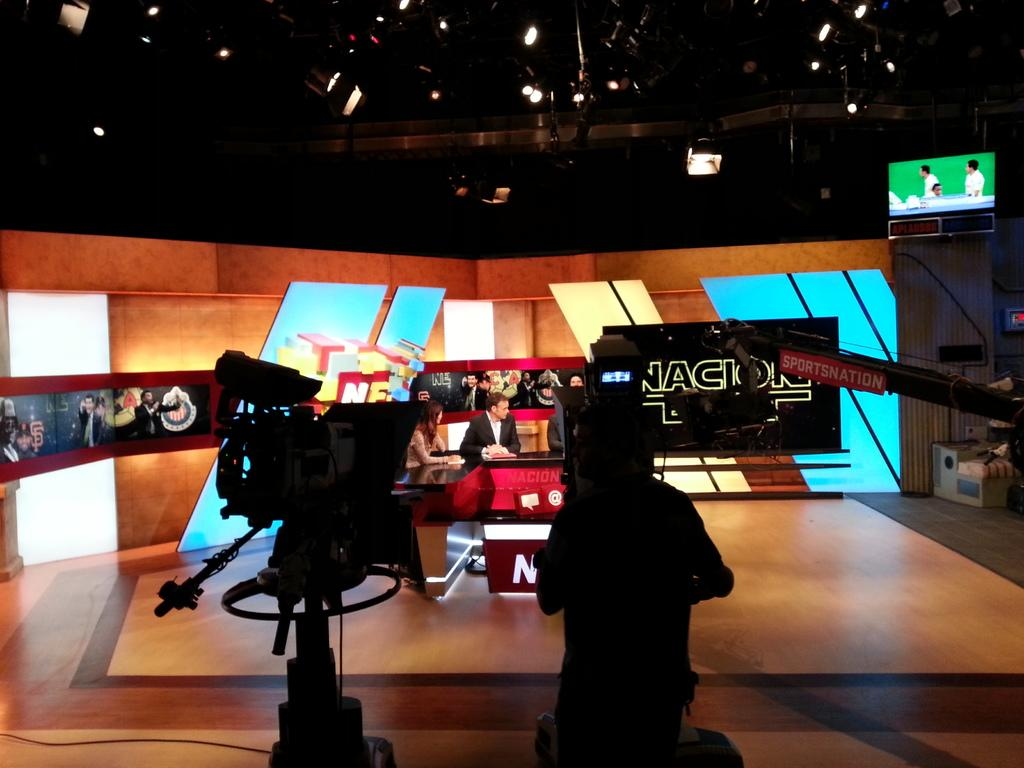<image>
Create a compact narrative representing the image presented. a tv studio and the letters AC on a screen 